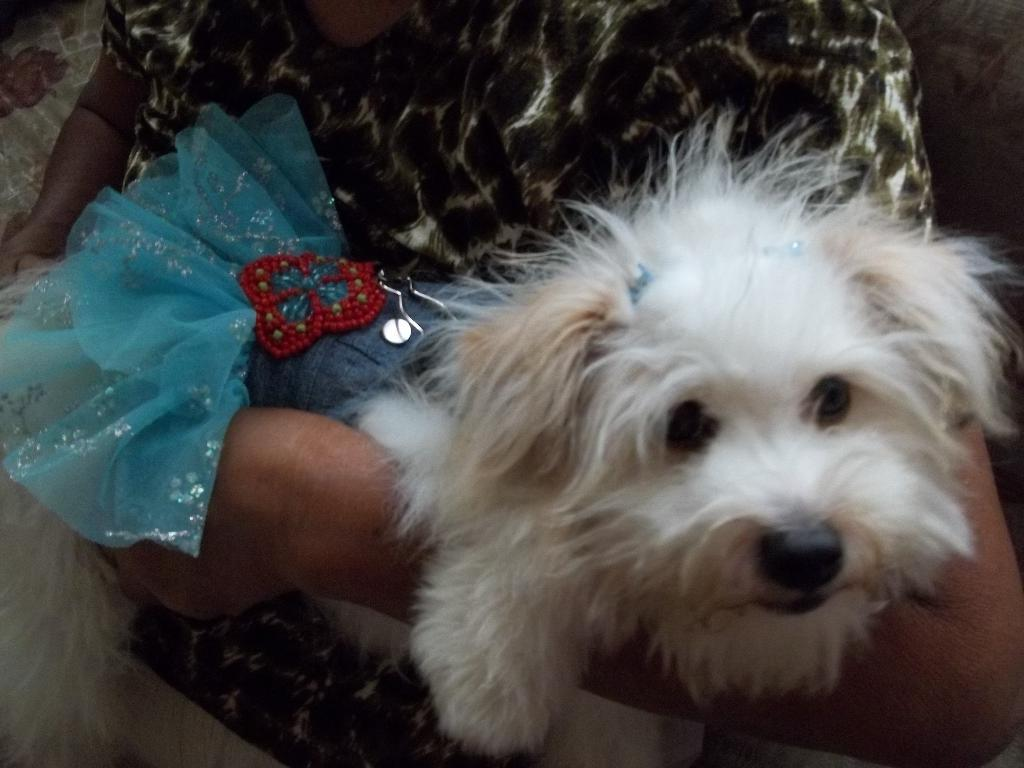What type of animal is present in the image? There is a dog in the image. What is the dog wearing in the image? The dog is wearing a costume in the image. Whose hand is visible in the image? A person's hand is visible in the image. What type of riddle can be solved by the dog in the image? There is no riddle present in the image, nor is there any indication that the dog is solving a riddle. Can you tell me how many islands are visible in the image? There are no islands present in the image. 